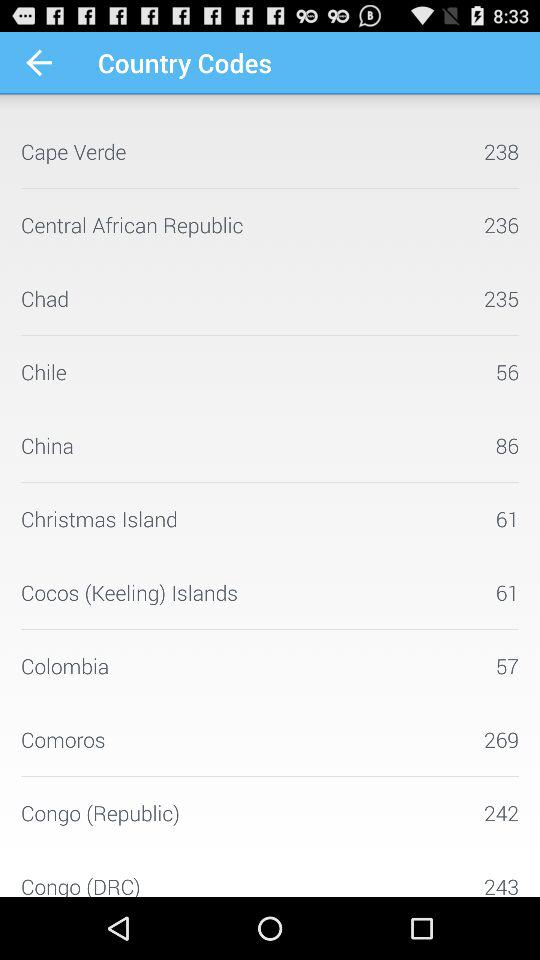What is the code for Cape Verde? The code for Cape Verde is 238. 